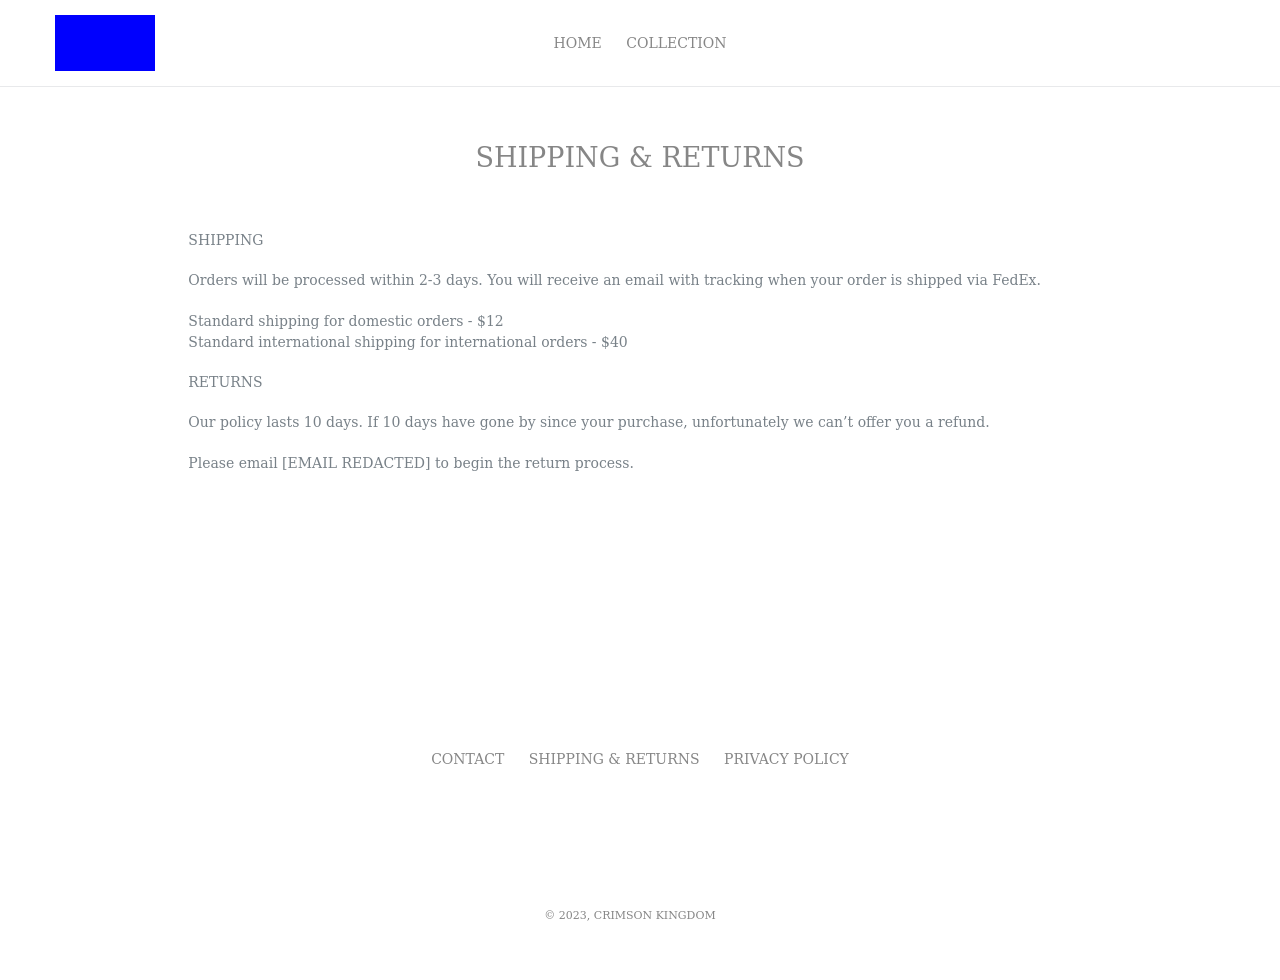Can you provide added details on how to implement a tracking system for the orders as displayed on this website? Certainly! To implement a tracking system, you would integrate backend technologies like JavaScript with an API from a courier service (e.g., FedEx). On the frontend, you could provide a form where customers enter their tracking number. A script would then fetch the tracking data from the courier's API and display it dynamically on the page. 